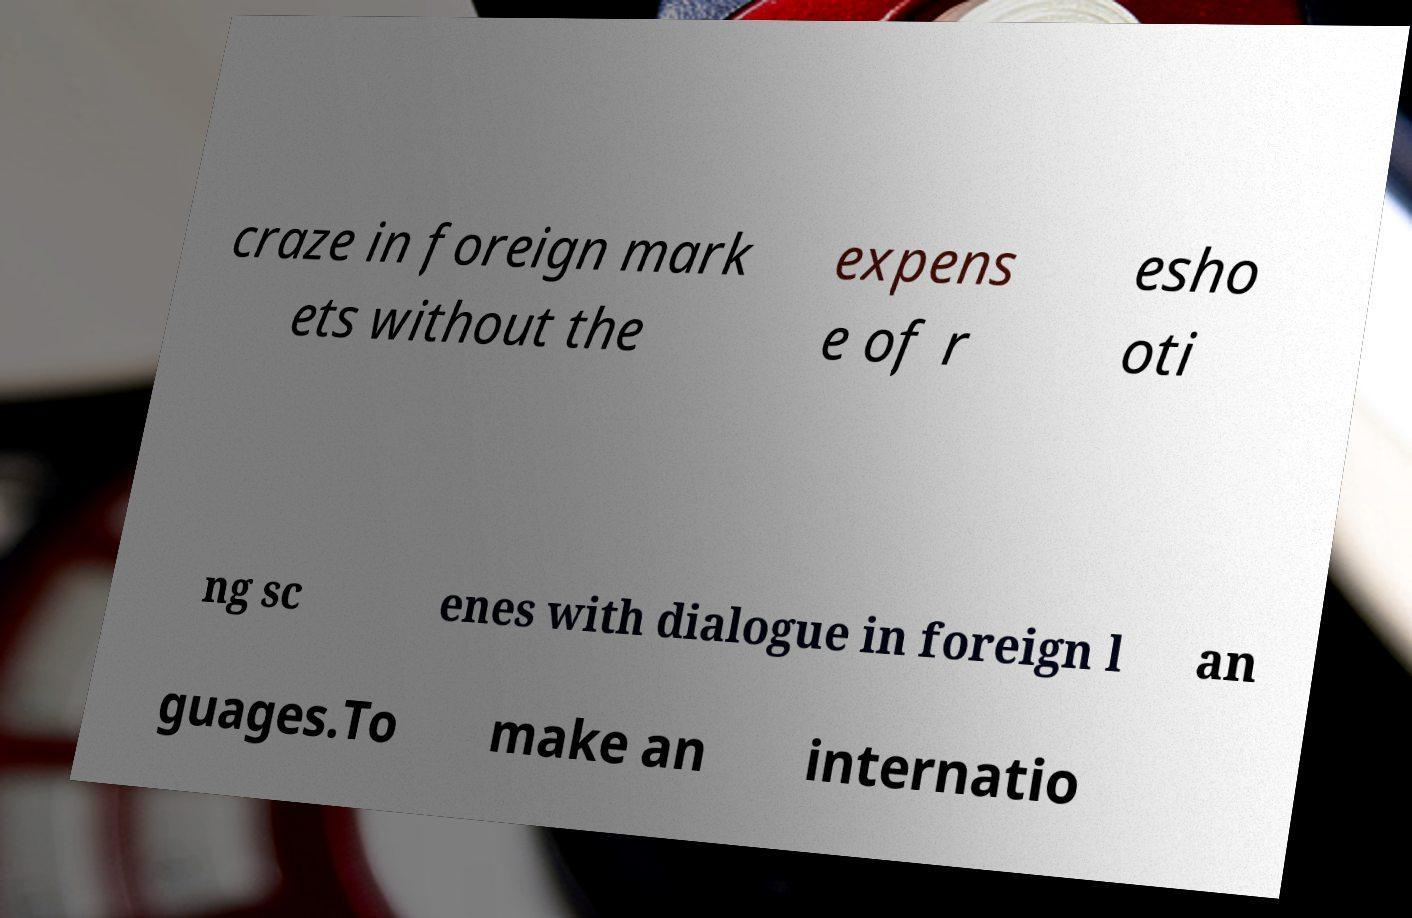There's text embedded in this image that I need extracted. Can you transcribe it verbatim? craze in foreign mark ets without the expens e of r esho oti ng sc enes with dialogue in foreign l an guages.To make an internatio 